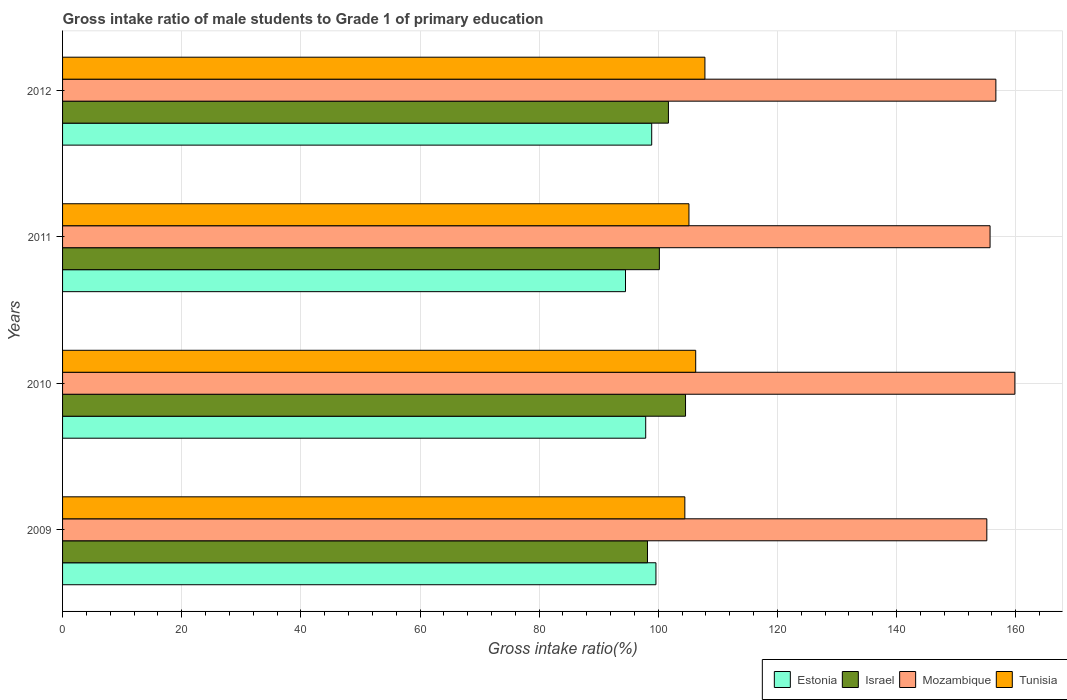How many different coloured bars are there?
Make the answer very short. 4. How many groups of bars are there?
Give a very brief answer. 4. Are the number of bars per tick equal to the number of legend labels?
Offer a very short reply. Yes. Are the number of bars on each tick of the Y-axis equal?
Your response must be concise. Yes. In how many cases, is the number of bars for a given year not equal to the number of legend labels?
Your answer should be compact. 0. What is the gross intake ratio in Mozambique in 2012?
Keep it short and to the point. 156.67. Across all years, what is the maximum gross intake ratio in Estonia?
Ensure brevity in your answer.  99.61. Across all years, what is the minimum gross intake ratio in Tunisia?
Your answer should be compact. 104.46. In which year was the gross intake ratio in Estonia minimum?
Provide a short and direct response. 2011. What is the total gross intake ratio in Israel in the graph?
Your answer should be compact. 404.65. What is the difference between the gross intake ratio in Tunisia in 2009 and that in 2010?
Your answer should be compact. -1.82. What is the difference between the gross intake ratio in Israel in 2010 and the gross intake ratio in Tunisia in 2012?
Make the answer very short. -3.25. What is the average gross intake ratio in Estonia per year?
Offer a very short reply. 97.72. In the year 2012, what is the difference between the gross intake ratio in Tunisia and gross intake ratio in Israel?
Provide a short and direct response. 6.13. In how many years, is the gross intake ratio in Estonia greater than 112 %?
Offer a terse response. 0. What is the ratio of the gross intake ratio in Israel in 2011 to that in 2012?
Ensure brevity in your answer.  0.99. What is the difference between the highest and the second highest gross intake ratio in Israel?
Your answer should be compact. 2.87. What is the difference between the highest and the lowest gross intake ratio in Mozambique?
Offer a terse response. 4.71. Is the sum of the gross intake ratio in Israel in 2010 and 2011 greater than the maximum gross intake ratio in Tunisia across all years?
Provide a short and direct response. Yes. Is it the case that in every year, the sum of the gross intake ratio in Mozambique and gross intake ratio in Estonia is greater than the sum of gross intake ratio in Tunisia and gross intake ratio in Israel?
Provide a short and direct response. Yes. What does the 3rd bar from the top in 2012 represents?
Provide a succinct answer. Israel. What does the 1st bar from the bottom in 2011 represents?
Ensure brevity in your answer.  Estonia. Is it the case that in every year, the sum of the gross intake ratio in Israel and gross intake ratio in Mozambique is greater than the gross intake ratio in Tunisia?
Your answer should be compact. Yes. How many years are there in the graph?
Offer a very short reply. 4. Are the values on the major ticks of X-axis written in scientific E-notation?
Your response must be concise. No. Does the graph contain any zero values?
Provide a short and direct response. No. Does the graph contain grids?
Provide a short and direct response. Yes. How many legend labels are there?
Your answer should be very brief. 4. How are the legend labels stacked?
Keep it short and to the point. Horizontal. What is the title of the graph?
Provide a short and direct response. Gross intake ratio of male students to Grade 1 of primary education. Does "Iceland" appear as one of the legend labels in the graph?
Offer a terse response. No. What is the label or title of the X-axis?
Your answer should be very brief. Gross intake ratio(%). What is the label or title of the Y-axis?
Your response must be concise. Years. What is the Gross intake ratio(%) in Estonia in 2009?
Provide a succinct answer. 99.61. What is the Gross intake ratio(%) in Israel in 2009?
Give a very brief answer. 98.19. What is the Gross intake ratio(%) of Mozambique in 2009?
Make the answer very short. 155.15. What is the Gross intake ratio(%) in Tunisia in 2009?
Offer a terse response. 104.46. What is the Gross intake ratio(%) of Estonia in 2010?
Give a very brief answer. 97.89. What is the Gross intake ratio(%) of Israel in 2010?
Keep it short and to the point. 104.58. What is the Gross intake ratio(%) of Mozambique in 2010?
Keep it short and to the point. 159.86. What is the Gross intake ratio(%) of Tunisia in 2010?
Offer a terse response. 106.28. What is the Gross intake ratio(%) of Estonia in 2011?
Your answer should be very brief. 94.5. What is the Gross intake ratio(%) in Israel in 2011?
Provide a short and direct response. 100.18. What is the Gross intake ratio(%) in Mozambique in 2011?
Keep it short and to the point. 155.69. What is the Gross intake ratio(%) of Tunisia in 2011?
Offer a very short reply. 105.15. What is the Gross intake ratio(%) in Estonia in 2012?
Provide a short and direct response. 98.9. What is the Gross intake ratio(%) of Israel in 2012?
Make the answer very short. 101.7. What is the Gross intake ratio(%) in Mozambique in 2012?
Provide a succinct answer. 156.67. What is the Gross intake ratio(%) in Tunisia in 2012?
Your answer should be compact. 107.83. Across all years, what is the maximum Gross intake ratio(%) of Estonia?
Ensure brevity in your answer.  99.61. Across all years, what is the maximum Gross intake ratio(%) in Israel?
Provide a succinct answer. 104.58. Across all years, what is the maximum Gross intake ratio(%) in Mozambique?
Offer a very short reply. 159.86. Across all years, what is the maximum Gross intake ratio(%) in Tunisia?
Your answer should be compact. 107.83. Across all years, what is the minimum Gross intake ratio(%) in Estonia?
Your answer should be compact. 94.5. Across all years, what is the minimum Gross intake ratio(%) in Israel?
Provide a succinct answer. 98.19. Across all years, what is the minimum Gross intake ratio(%) in Mozambique?
Offer a terse response. 155.15. Across all years, what is the minimum Gross intake ratio(%) of Tunisia?
Your answer should be very brief. 104.46. What is the total Gross intake ratio(%) of Estonia in the graph?
Your response must be concise. 390.89. What is the total Gross intake ratio(%) in Israel in the graph?
Offer a very short reply. 404.65. What is the total Gross intake ratio(%) of Mozambique in the graph?
Your answer should be compact. 627.38. What is the total Gross intake ratio(%) in Tunisia in the graph?
Offer a terse response. 423.72. What is the difference between the Gross intake ratio(%) in Estonia in 2009 and that in 2010?
Give a very brief answer. 1.72. What is the difference between the Gross intake ratio(%) in Israel in 2009 and that in 2010?
Offer a very short reply. -6.39. What is the difference between the Gross intake ratio(%) of Mozambique in 2009 and that in 2010?
Your answer should be compact. -4.71. What is the difference between the Gross intake ratio(%) of Tunisia in 2009 and that in 2010?
Provide a succinct answer. -1.82. What is the difference between the Gross intake ratio(%) in Estonia in 2009 and that in 2011?
Offer a terse response. 5.11. What is the difference between the Gross intake ratio(%) in Israel in 2009 and that in 2011?
Keep it short and to the point. -1.99. What is the difference between the Gross intake ratio(%) in Mozambique in 2009 and that in 2011?
Make the answer very short. -0.54. What is the difference between the Gross intake ratio(%) of Tunisia in 2009 and that in 2011?
Offer a very short reply. -0.69. What is the difference between the Gross intake ratio(%) in Estonia in 2009 and that in 2012?
Your answer should be very brief. 0.71. What is the difference between the Gross intake ratio(%) in Israel in 2009 and that in 2012?
Make the answer very short. -3.51. What is the difference between the Gross intake ratio(%) in Mozambique in 2009 and that in 2012?
Ensure brevity in your answer.  -1.52. What is the difference between the Gross intake ratio(%) in Tunisia in 2009 and that in 2012?
Give a very brief answer. -3.37. What is the difference between the Gross intake ratio(%) in Estonia in 2010 and that in 2011?
Provide a succinct answer. 3.39. What is the difference between the Gross intake ratio(%) in Israel in 2010 and that in 2011?
Provide a succinct answer. 4.39. What is the difference between the Gross intake ratio(%) of Mozambique in 2010 and that in 2011?
Your answer should be compact. 4.16. What is the difference between the Gross intake ratio(%) in Tunisia in 2010 and that in 2011?
Give a very brief answer. 1.13. What is the difference between the Gross intake ratio(%) in Estonia in 2010 and that in 2012?
Give a very brief answer. -1.01. What is the difference between the Gross intake ratio(%) of Israel in 2010 and that in 2012?
Provide a short and direct response. 2.87. What is the difference between the Gross intake ratio(%) of Mozambique in 2010 and that in 2012?
Your response must be concise. 3.19. What is the difference between the Gross intake ratio(%) of Tunisia in 2010 and that in 2012?
Make the answer very short. -1.55. What is the difference between the Gross intake ratio(%) in Estonia in 2011 and that in 2012?
Your response must be concise. -4.4. What is the difference between the Gross intake ratio(%) in Israel in 2011 and that in 2012?
Provide a succinct answer. -1.52. What is the difference between the Gross intake ratio(%) in Mozambique in 2011 and that in 2012?
Give a very brief answer. -0.98. What is the difference between the Gross intake ratio(%) of Tunisia in 2011 and that in 2012?
Ensure brevity in your answer.  -2.68. What is the difference between the Gross intake ratio(%) in Estonia in 2009 and the Gross intake ratio(%) in Israel in 2010?
Keep it short and to the point. -4.97. What is the difference between the Gross intake ratio(%) in Estonia in 2009 and the Gross intake ratio(%) in Mozambique in 2010?
Give a very brief answer. -60.25. What is the difference between the Gross intake ratio(%) of Estonia in 2009 and the Gross intake ratio(%) of Tunisia in 2010?
Keep it short and to the point. -6.67. What is the difference between the Gross intake ratio(%) in Israel in 2009 and the Gross intake ratio(%) in Mozambique in 2010?
Provide a short and direct response. -61.67. What is the difference between the Gross intake ratio(%) of Israel in 2009 and the Gross intake ratio(%) of Tunisia in 2010?
Offer a terse response. -8.09. What is the difference between the Gross intake ratio(%) of Mozambique in 2009 and the Gross intake ratio(%) of Tunisia in 2010?
Offer a terse response. 48.87. What is the difference between the Gross intake ratio(%) of Estonia in 2009 and the Gross intake ratio(%) of Israel in 2011?
Your answer should be very brief. -0.58. What is the difference between the Gross intake ratio(%) in Estonia in 2009 and the Gross intake ratio(%) in Mozambique in 2011?
Give a very brief answer. -56.09. What is the difference between the Gross intake ratio(%) of Estonia in 2009 and the Gross intake ratio(%) of Tunisia in 2011?
Your answer should be very brief. -5.54. What is the difference between the Gross intake ratio(%) of Israel in 2009 and the Gross intake ratio(%) of Mozambique in 2011?
Make the answer very short. -57.51. What is the difference between the Gross intake ratio(%) of Israel in 2009 and the Gross intake ratio(%) of Tunisia in 2011?
Make the answer very short. -6.96. What is the difference between the Gross intake ratio(%) of Mozambique in 2009 and the Gross intake ratio(%) of Tunisia in 2011?
Provide a short and direct response. 50. What is the difference between the Gross intake ratio(%) in Estonia in 2009 and the Gross intake ratio(%) in Israel in 2012?
Offer a very short reply. -2.1. What is the difference between the Gross intake ratio(%) of Estonia in 2009 and the Gross intake ratio(%) of Mozambique in 2012?
Ensure brevity in your answer.  -57.06. What is the difference between the Gross intake ratio(%) of Estonia in 2009 and the Gross intake ratio(%) of Tunisia in 2012?
Provide a short and direct response. -8.22. What is the difference between the Gross intake ratio(%) of Israel in 2009 and the Gross intake ratio(%) of Mozambique in 2012?
Your response must be concise. -58.48. What is the difference between the Gross intake ratio(%) in Israel in 2009 and the Gross intake ratio(%) in Tunisia in 2012?
Give a very brief answer. -9.64. What is the difference between the Gross intake ratio(%) in Mozambique in 2009 and the Gross intake ratio(%) in Tunisia in 2012?
Give a very brief answer. 47.32. What is the difference between the Gross intake ratio(%) in Estonia in 2010 and the Gross intake ratio(%) in Israel in 2011?
Ensure brevity in your answer.  -2.29. What is the difference between the Gross intake ratio(%) in Estonia in 2010 and the Gross intake ratio(%) in Mozambique in 2011?
Your answer should be compact. -57.81. What is the difference between the Gross intake ratio(%) of Estonia in 2010 and the Gross intake ratio(%) of Tunisia in 2011?
Ensure brevity in your answer.  -7.26. What is the difference between the Gross intake ratio(%) of Israel in 2010 and the Gross intake ratio(%) of Mozambique in 2011?
Offer a very short reply. -51.12. What is the difference between the Gross intake ratio(%) of Israel in 2010 and the Gross intake ratio(%) of Tunisia in 2011?
Your answer should be very brief. -0.57. What is the difference between the Gross intake ratio(%) in Mozambique in 2010 and the Gross intake ratio(%) in Tunisia in 2011?
Offer a very short reply. 54.71. What is the difference between the Gross intake ratio(%) of Estonia in 2010 and the Gross intake ratio(%) of Israel in 2012?
Provide a short and direct response. -3.81. What is the difference between the Gross intake ratio(%) of Estonia in 2010 and the Gross intake ratio(%) of Mozambique in 2012?
Make the answer very short. -58.78. What is the difference between the Gross intake ratio(%) of Estonia in 2010 and the Gross intake ratio(%) of Tunisia in 2012?
Offer a terse response. -9.94. What is the difference between the Gross intake ratio(%) of Israel in 2010 and the Gross intake ratio(%) of Mozambique in 2012?
Your response must be concise. -52.1. What is the difference between the Gross intake ratio(%) of Israel in 2010 and the Gross intake ratio(%) of Tunisia in 2012?
Offer a terse response. -3.25. What is the difference between the Gross intake ratio(%) in Mozambique in 2010 and the Gross intake ratio(%) in Tunisia in 2012?
Offer a terse response. 52.03. What is the difference between the Gross intake ratio(%) of Estonia in 2011 and the Gross intake ratio(%) of Israel in 2012?
Provide a short and direct response. -7.21. What is the difference between the Gross intake ratio(%) in Estonia in 2011 and the Gross intake ratio(%) in Mozambique in 2012?
Provide a short and direct response. -62.17. What is the difference between the Gross intake ratio(%) of Estonia in 2011 and the Gross intake ratio(%) of Tunisia in 2012?
Provide a succinct answer. -13.33. What is the difference between the Gross intake ratio(%) in Israel in 2011 and the Gross intake ratio(%) in Mozambique in 2012?
Offer a very short reply. -56.49. What is the difference between the Gross intake ratio(%) in Israel in 2011 and the Gross intake ratio(%) in Tunisia in 2012?
Make the answer very short. -7.65. What is the difference between the Gross intake ratio(%) in Mozambique in 2011 and the Gross intake ratio(%) in Tunisia in 2012?
Offer a terse response. 47.87. What is the average Gross intake ratio(%) of Estonia per year?
Keep it short and to the point. 97.72. What is the average Gross intake ratio(%) in Israel per year?
Keep it short and to the point. 101.16. What is the average Gross intake ratio(%) of Mozambique per year?
Give a very brief answer. 156.84. What is the average Gross intake ratio(%) in Tunisia per year?
Offer a terse response. 105.93. In the year 2009, what is the difference between the Gross intake ratio(%) in Estonia and Gross intake ratio(%) in Israel?
Your answer should be compact. 1.42. In the year 2009, what is the difference between the Gross intake ratio(%) in Estonia and Gross intake ratio(%) in Mozambique?
Offer a terse response. -55.54. In the year 2009, what is the difference between the Gross intake ratio(%) of Estonia and Gross intake ratio(%) of Tunisia?
Your answer should be very brief. -4.85. In the year 2009, what is the difference between the Gross intake ratio(%) of Israel and Gross intake ratio(%) of Mozambique?
Ensure brevity in your answer.  -56.96. In the year 2009, what is the difference between the Gross intake ratio(%) in Israel and Gross intake ratio(%) in Tunisia?
Give a very brief answer. -6.27. In the year 2009, what is the difference between the Gross intake ratio(%) in Mozambique and Gross intake ratio(%) in Tunisia?
Your answer should be compact. 50.69. In the year 2010, what is the difference between the Gross intake ratio(%) in Estonia and Gross intake ratio(%) in Israel?
Your response must be concise. -6.69. In the year 2010, what is the difference between the Gross intake ratio(%) in Estonia and Gross intake ratio(%) in Mozambique?
Ensure brevity in your answer.  -61.97. In the year 2010, what is the difference between the Gross intake ratio(%) of Estonia and Gross intake ratio(%) of Tunisia?
Your answer should be very brief. -8.39. In the year 2010, what is the difference between the Gross intake ratio(%) in Israel and Gross intake ratio(%) in Mozambique?
Keep it short and to the point. -55.28. In the year 2010, what is the difference between the Gross intake ratio(%) of Israel and Gross intake ratio(%) of Tunisia?
Offer a very short reply. -1.71. In the year 2010, what is the difference between the Gross intake ratio(%) of Mozambique and Gross intake ratio(%) of Tunisia?
Give a very brief answer. 53.58. In the year 2011, what is the difference between the Gross intake ratio(%) in Estonia and Gross intake ratio(%) in Israel?
Keep it short and to the point. -5.69. In the year 2011, what is the difference between the Gross intake ratio(%) in Estonia and Gross intake ratio(%) in Mozambique?
Provide a succinct answer. -61.2. In the year 2011, what is the difference between the Gross intake ratio(%) of Estonia and Gross intake ratio(%) of Tunisia?
Give a very brief answer. -10.65. In the year 2011, what is the difference between the Gross intake ratio(%) in Israel and Gross intake ratio(%) in Mozambique?
Make the answer very short. -55.51. In the year 2011, what is the difference between the Gross intake ratio(%) in Israel and Gross intake ratio(%) in Tunisia?
Give a very brief answer. -4.97. In the year 2011, what is the difference between the Gross intake ratio(%) of Mozambique and Gross intake ratio(%) of Tunisia?
Make the answer very short. 50.55. In the year 2012, what is the difference between the Gross intake ratio(%) in Estonia and Gross intake ratio(%) in Israel?
Ensure brevity in your answer.  -2.81. In the year 2012, what is the difference between the Gross intake ratio(%) in Estonia and Gross intake ratio(%) in Mozambique?
Provide a short and direct response. -57.77. In the year 2012, what is the difference between the Gross intake ratio(%) in Estonia and Gross intake ratio(%) in Tunisia?
Provide a short and direct response. -8.93. In the year 2012, what is the difference between the Gross intake ratio(%) of Israel and Gross intake ratio(%) of Mozambique?
Ensure brevity in your answer.  -54.97. In the year 2012, what is the difference between the Gross intake ratio(%) in Israel and Gross intake ratio(%) in Tunisia?
Provide a succinct answer. -6.13. In the year 2012, what is the difference between the Gross intake ratio(%) of Mozambique and Gross intake ratio(%) of Tunisia?
Ensure brevity in your answer.  48.84. What is the ratio of the Gross intake ratio(%) of Estonia in 2009 to that in 2010?
Provide a short and direct response. 1.02. What is the ratio of the Gross intake ratio(%) of Israel in 2009 to that in 2010?
Ensure brevity in your answer.  0.94. What is the ratio of the Gross intake ratio(%) in Mozambique in 2009 to that in 2010?
Give a very brief answer. 0.97. What is the ratio of the Gross intake ratio(%) of Tunisia in 2009 to that in 2010?
Your answer should be very brief. 0.98. What is the ratio of the Gross intake ratio(%) in Estonia in 2009 to that in 2011?
Keep it short and to the point. 1.05. What is the ratio of the Gross intake ratio(%) in Israel in 2009 to that in 2011?
Your answer should be compact. 0.98. What is the ratio of the Gross intake ratio(%) in Tunisia in 2009 to that in 2011?
Offer a terse response. 0.99. What is the ratio of the Gross intake ratio(%) of Estonia in 2009 to that in 2012?
Make the answer very short. 1.01. What is the ratio of the Gross intake ratio(%) in Israel in 2009 to that in 2012?
Offer a terse response. 0.97. What is the ratio of the Gross intake ratio(%) of Mozambique in 2009 to that in 2012?
Keep it short and to the point. 0.99. What is the ratio of the Gross intake ratio(%) in Tunisia in 2009 to that in 2012?
Your answer should be compact. 0.97. What is the ratio of the Gross intake ratio(%) in Estonia in 2010 to that in 2011?
Provide a succinct answer. 1.04. What is the ratio of the Gross intake ratio(%) of Israel in 2010 to that in 2011?
Give a very brief answer. 1.04. What is the ratio of the Gross intake ratio(%) of Mozambique in 2010 to that in 2011?
Your response must be concise. 1.03. What is the ratio of the Gross intake ratio(%) of Tunisia in 2010 to that in 2011?
Provide a succinct answer. 1.01. What is the ratio of the Gross intake ratio(%) of Estonia in 2010 to that in 2012?
Your answer should be very brief. 0.99. What is the ratio of the Gross intake ratio(%) of Israel in 2010 to that in 2012?
Your answer should be compact. 1.03. What is the ratio of the Gross intake ratio(%) in Mozambique in 2010 to that in 2012?
Your answer should be compact. 1.02. What is the ratio of the Gross intake ratio(%) of Tunisia in 2010 to that in 2012?
Ensure brevity in your answer.  0.99. What is the ratio of the Gross intake ratio(%) of Estonia in 2011 to that in 2012?
Provide a succinct answer. 0.96. What is the ratio of the Gross intake ratio(%) in Israel in 2011 to that in 2012?
Your answer should be compact. 0.99. What is the ratio of the Gross intake ratio(%) of Mozambique in 2011 to that in 2012?
Offer a very short reply. 0.99. What is the ratio of the Gross intake ratio(%) in Tunisia in 2011 to that in 2012?
Offer a very short reply. 0.98. What is the difference between the highest and the second highest Gross intake ratio(%) of Estonia?
Offer a very short reply. 0.71. What is the difference between the highest and the second highest Gross intake ratio(%) in Israel?
Your answer should be very brief. 2.87. What is the difference between the highest and the second highest Gross intake ratio(%) of Mozambique?
Provide a succinct answer. 3.19. What is the difference between the highest and the second highest Gross intake ratio(%) of Tunisia?
Keep it short and to the point. 1.55. What is the difference between the highest and the lowest Gross intake ratio(%) of Estonia?
Your response must be concise. 5.11. What is the difference between the highest and the lowest Gross intake ratio(%) in Israel?
Give a very brief answer. 6.39. What is the difference between the highest and the lowest Gross intake ratio(%) of Mozambique?
Your answer should be compact. 4.71. What is the difference between the highest and the lowest Gross intake ratio(%) in Tunisia?
Give a very brief answer. 3.37. 